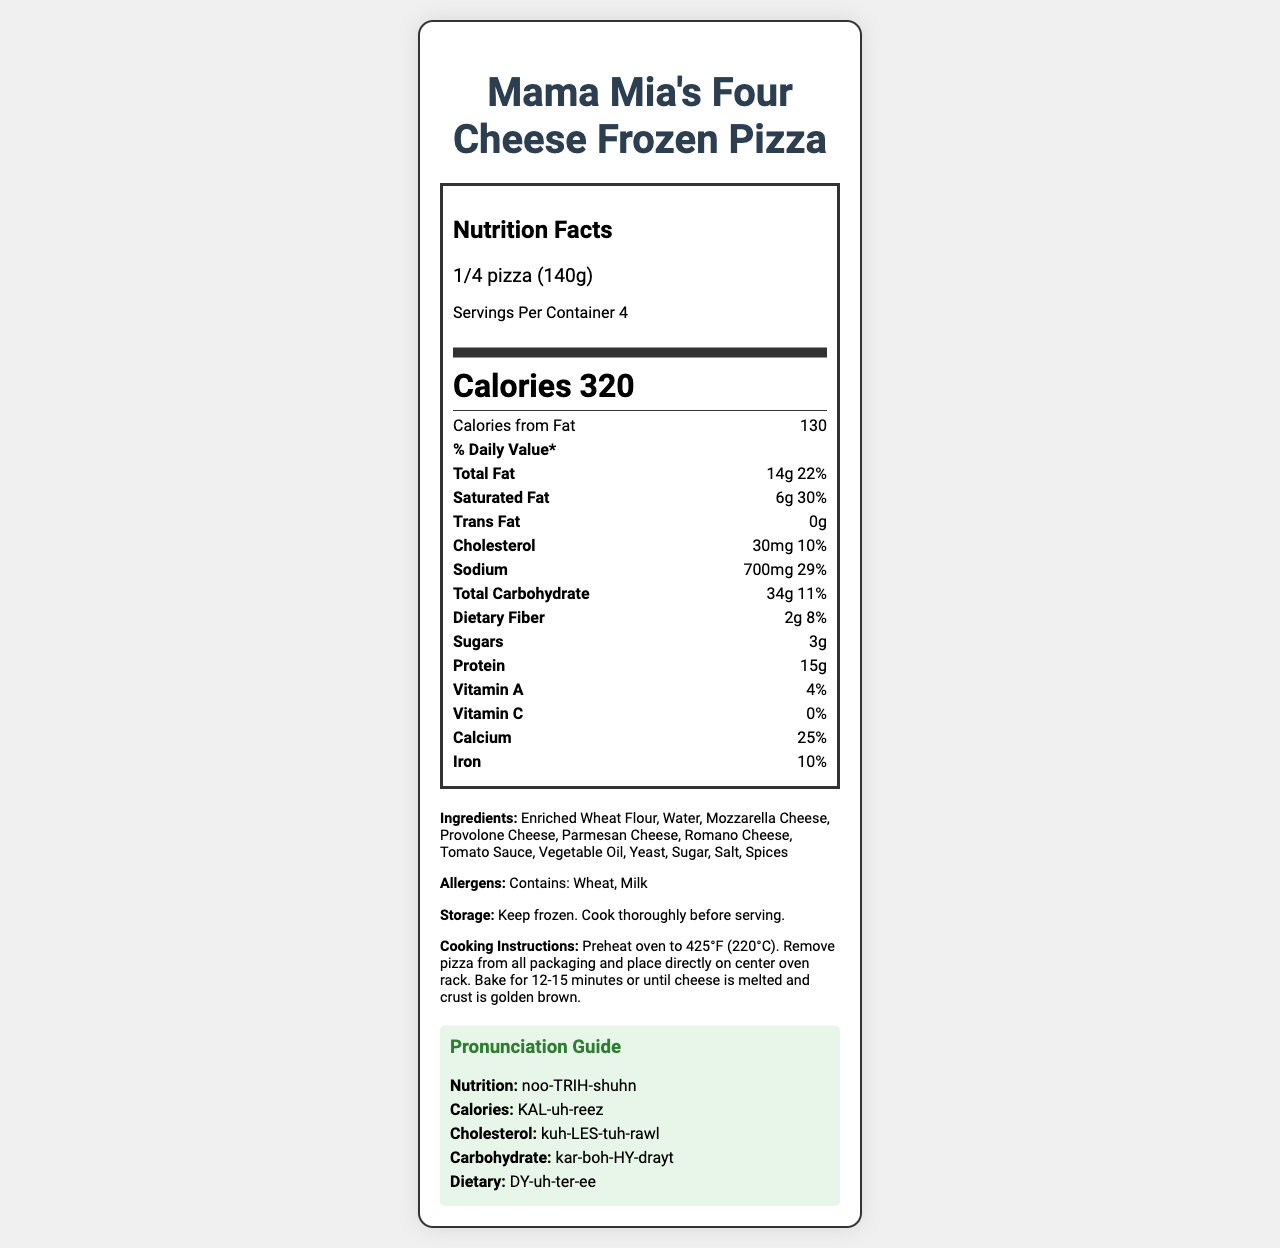How many servings are in Mama Mia's Four Cheese Frozen Pizza? The document states that there are 4 servings per container.
Answer: 4 What is the serving size for the pizza in grams? The serving size information indicates it is 140 grams.
Answer: 140 grams How many calories are there per serving? The calories per serving are specified as 320.
Answer: 320 calories What are the two main allergens in the pizza? The document lists Wheat and Milk as the main allergens.
Answer: Wheat and Milk How much Total Fat is in one serving of the pizza? The nutrient information shows that one serving contains 14 grams of Total Fat.
Answer: 14 grams Which vitamin has the highest daily value percentage in this pizza? A. Vitamin A B. Vitamin C C. Calcium D. Iron The document shows Calcium with a 25% daily value, which is the highest among the listed vitamins and minerals.
Answer: C. Calcium What percentage of the daily value of Saturated Fat does one serving contain? A. 22% B. 30% C. 29% D. 11% The Saturated Fat daily value percentage is listed as 30%.
Answer: B. 30% Is there any Trans Fat in one serving of this pizza? The document lists 0 grams of Trans Fat.
Answer: No Can the Nutrition Facts Label provide the cooking time for this pizza? The label includes cooking instructions: "Bake for 12-15 minutes or until cheese is melted and crust is golden brown."
Answer: Yes Summarize the Nutrition Facts for Mama Mia's Four Cheese Frozen Pizza. This summary provides an overview of the document, highlighting the key nutritional and additional information included in the label.
Answer: The document provides detailed nutritional information for Mama Mia's Four Cheese Frozen Pizza. Each serving size is 1/4 pizza (140 grams), with 4 servings per container. Each serving contains 320 calories, 14 grams of Total Fat, 6 grams of Saturated Fat, 0 grams of Trans Fat, 30 mg of Cholesterol, 700 mg of Sodium, 34 grams of Total Carbohydrate, 2 grams of Dietary Fiber, 3 grams of Sugars, and 15 grams of Protein. The label also lists 4% Vitamin A, 0% Vitamin C, 25% Calcium, and 10% Iron in the vitamin and mineral section. Additionally, it lists the ingredients, allergens, storage, and cooking instructions, along with a pronunciation guide. What is the total amount of Sugars found in the entire pizza? The document provides the amount of Sugars per serving (3 grams), but does not specify the total amount for the entire pizza.
Answer: Not enough information What is the product name of the frozen pizza? The top of the document prominently displays the product name as Mama Mia's Four Cheese Frozen Pizza.
Answer: Mama Mia's Four Cheese Frozen Pizza 